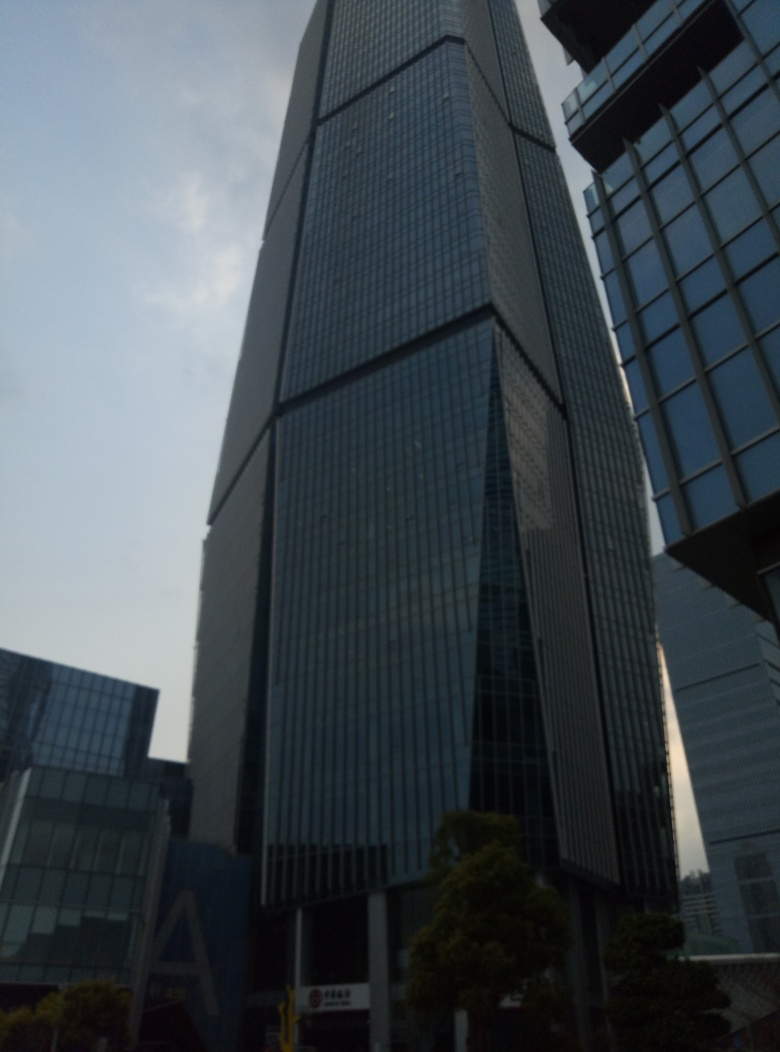This building looks modern. Can you tell me more about its architecture and design? Certainly! The building in the image boasts a contemporary design, characterized by its glass facade which reflects its surroundings and provides a sense of openness. The use of glass often signifies a modern aesthetic which may feature clean lines and an emphasis on light and transparency. The building's towering height and structural elements suggest it is likely used for commercial or office purposes, evident from the uniform window patterns and absence of balconies which are typical for residential buildings. 